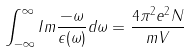<formula> <loc_0><loc_0><loc_500><loc_500>\int _ { - \infty } ^ { \infty } I m \frac { - \omega } { \epsilon ( \omega ) } d \omega = \frac { 4 \pi ^ { 2 } e ^ { 2 } N } { m V }</formula> 